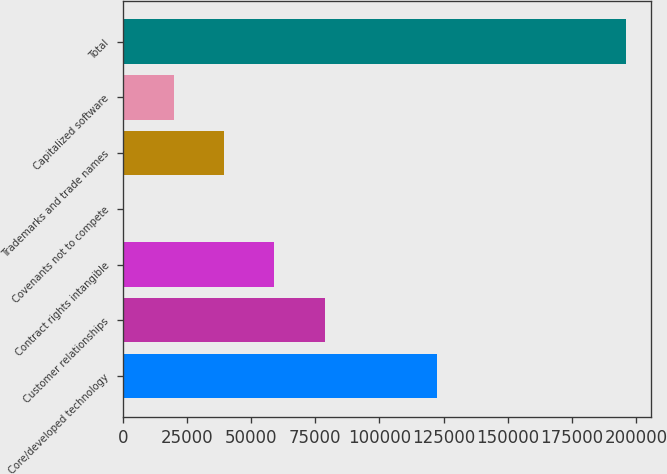Convert chart. <chart><loc_0><loc_0><loc_500><loc_500><bar_chart><fcel>Core/developed technology<fcel>Customer relationships<fcel>Contract rights intangible<fcel>Covenants not to compete<fcel>Trademarks and trade names<fcel>Capitalized software<fcel>Total<nl><fcel>122537<fcel>78667.4<fcel>59106.8<fcel>425<fcel>39546.2<fcel>19985.6<fcel>196031<nl></chart> 